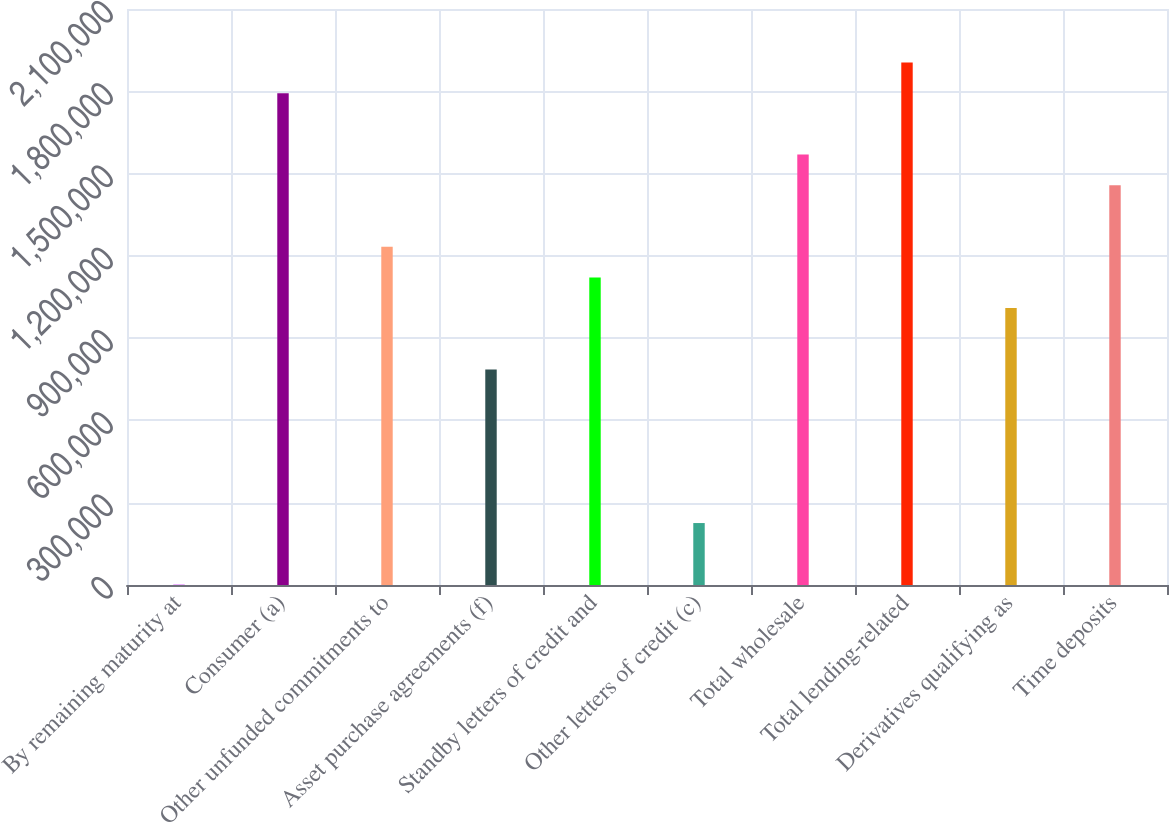Convert chart to OTSL. <chart><loc_0><loc_0><loc_500><loc_500><bar_chart><fcel>By remaining maturity at<fcel>Consumer (a)<fcel>Other unfunded commitments to<fcel>Asset purchase agreements (f)<fcel>Standby letters of credit and<fcel>Other letters of credit (c)<fcel>Total wholesale<fcel>Total lending-related<fcel>Derivatives qualifying as<fcel>Time deposits<nl><fcel>2008<fcel>1.793e+06<fcel>1.23332e+06<fcel>785567<fcel>1.12138e+06<fcel>225882<fcel>1.56913e+06<fcel>1.90494e+06<fcel>1.00944e+06<fcel>1.45719e+06<nl></chart> 